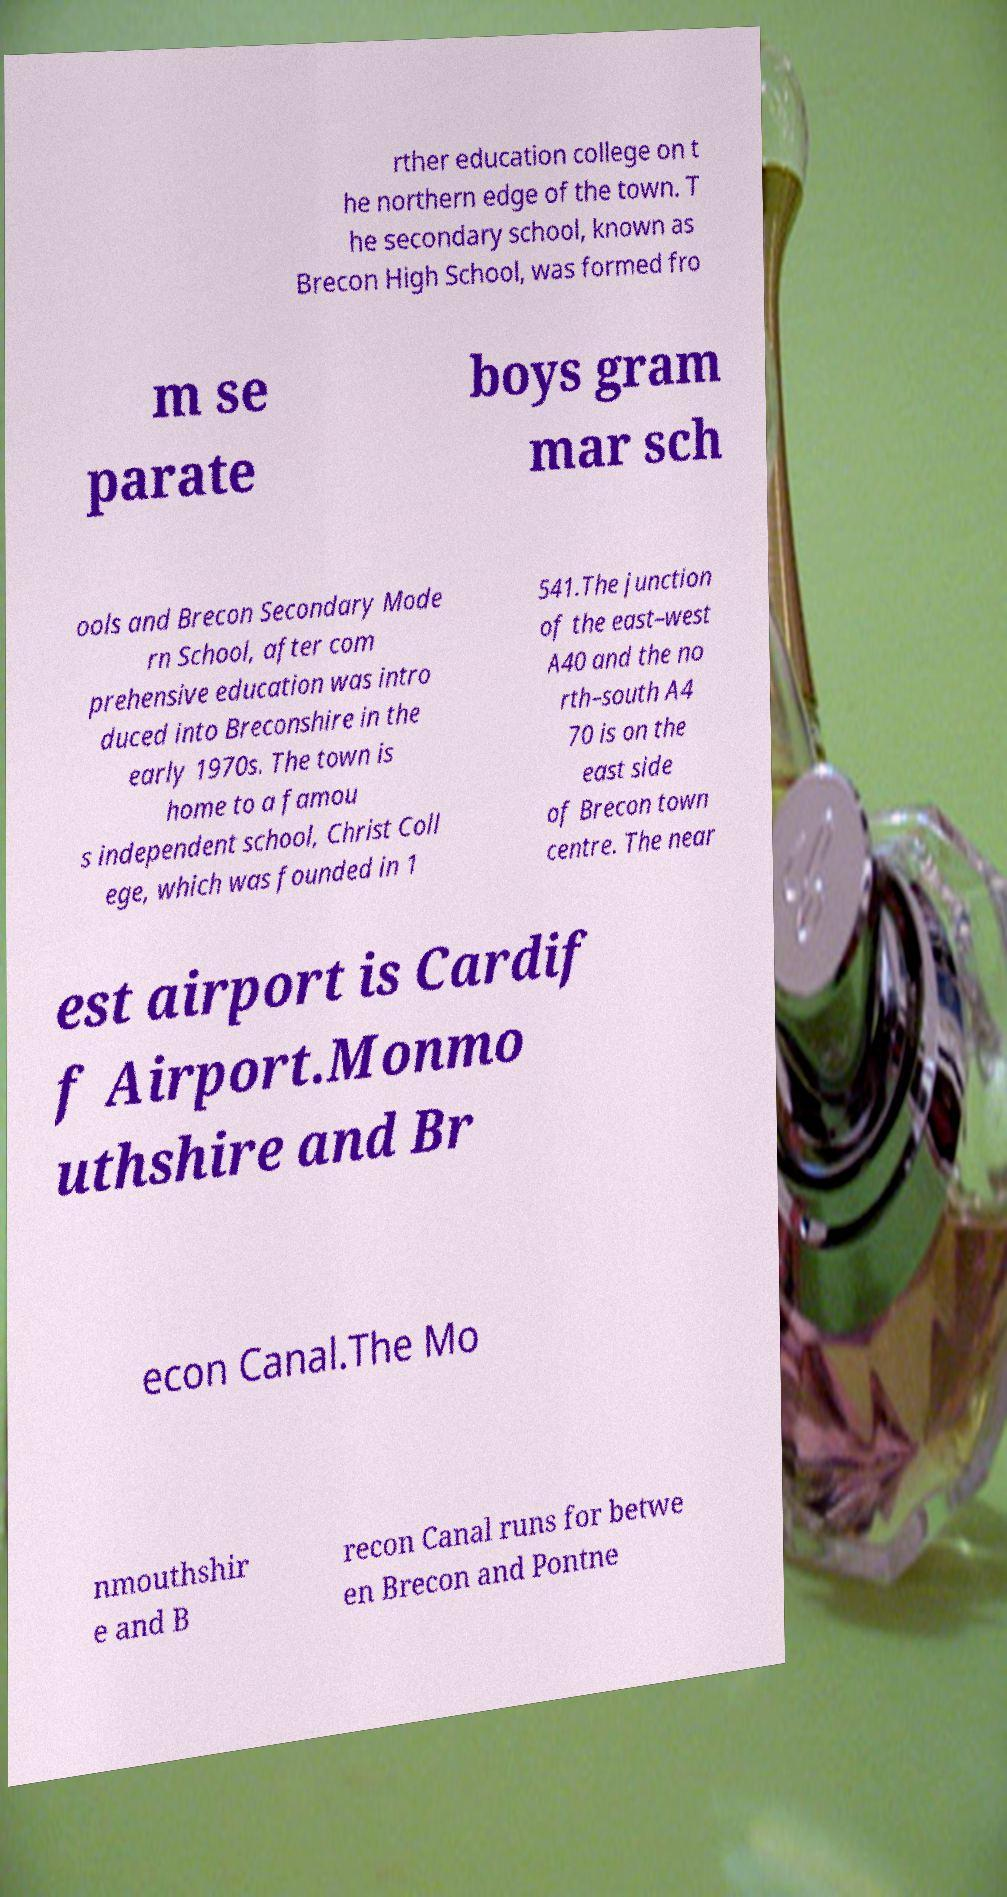For documentation purposes, I need the text within this image transcribed. Could you provide that? rther education college on t he northern edge of the town. T he secondary school, known as Brecon High School, was formed fro m se parate boys gram mar sch ools and Brecon Secondary Mode rn School, after com prehensive education was intro duced into Breconshire in the early 1970s. The town is home to a famou s independent school, Christ Coll ege, which was founded in 1 541.The junction of the east–west A40 and the no rth–south A4 70 is on the east side of Brecon town centre. The near est airport is Cardif f Airport.Monmo uthshire and Br econ Canal.The Mo nmouthshir e and B recon Canal runs for betwe en Brecon and Pontne 